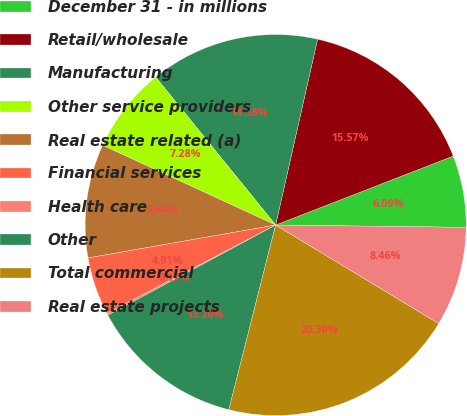Convert chart to OTSL. <chart><loc_0><loc_0><loc_500><loc_500><pie_chart><fcel>December 31 - in millions<fcel>Retail/wholesale<fcel>Manufacturing<fcel>Other service providers<fcel>Real estate related (a)<fcel>Financial services<fcel>Health care<fcel>Other<fcel>Total commercial<fcel>Real estate projects<nl><fcel>6.09%<fcel>15.57%<fcel>14.38%<fcel>7.28%<fcel>9.64%<fcel>4.91%<fcel>0.17%<fcel>13.2%<fcel>20.3%<fcel>8.46%<nl></chart> 